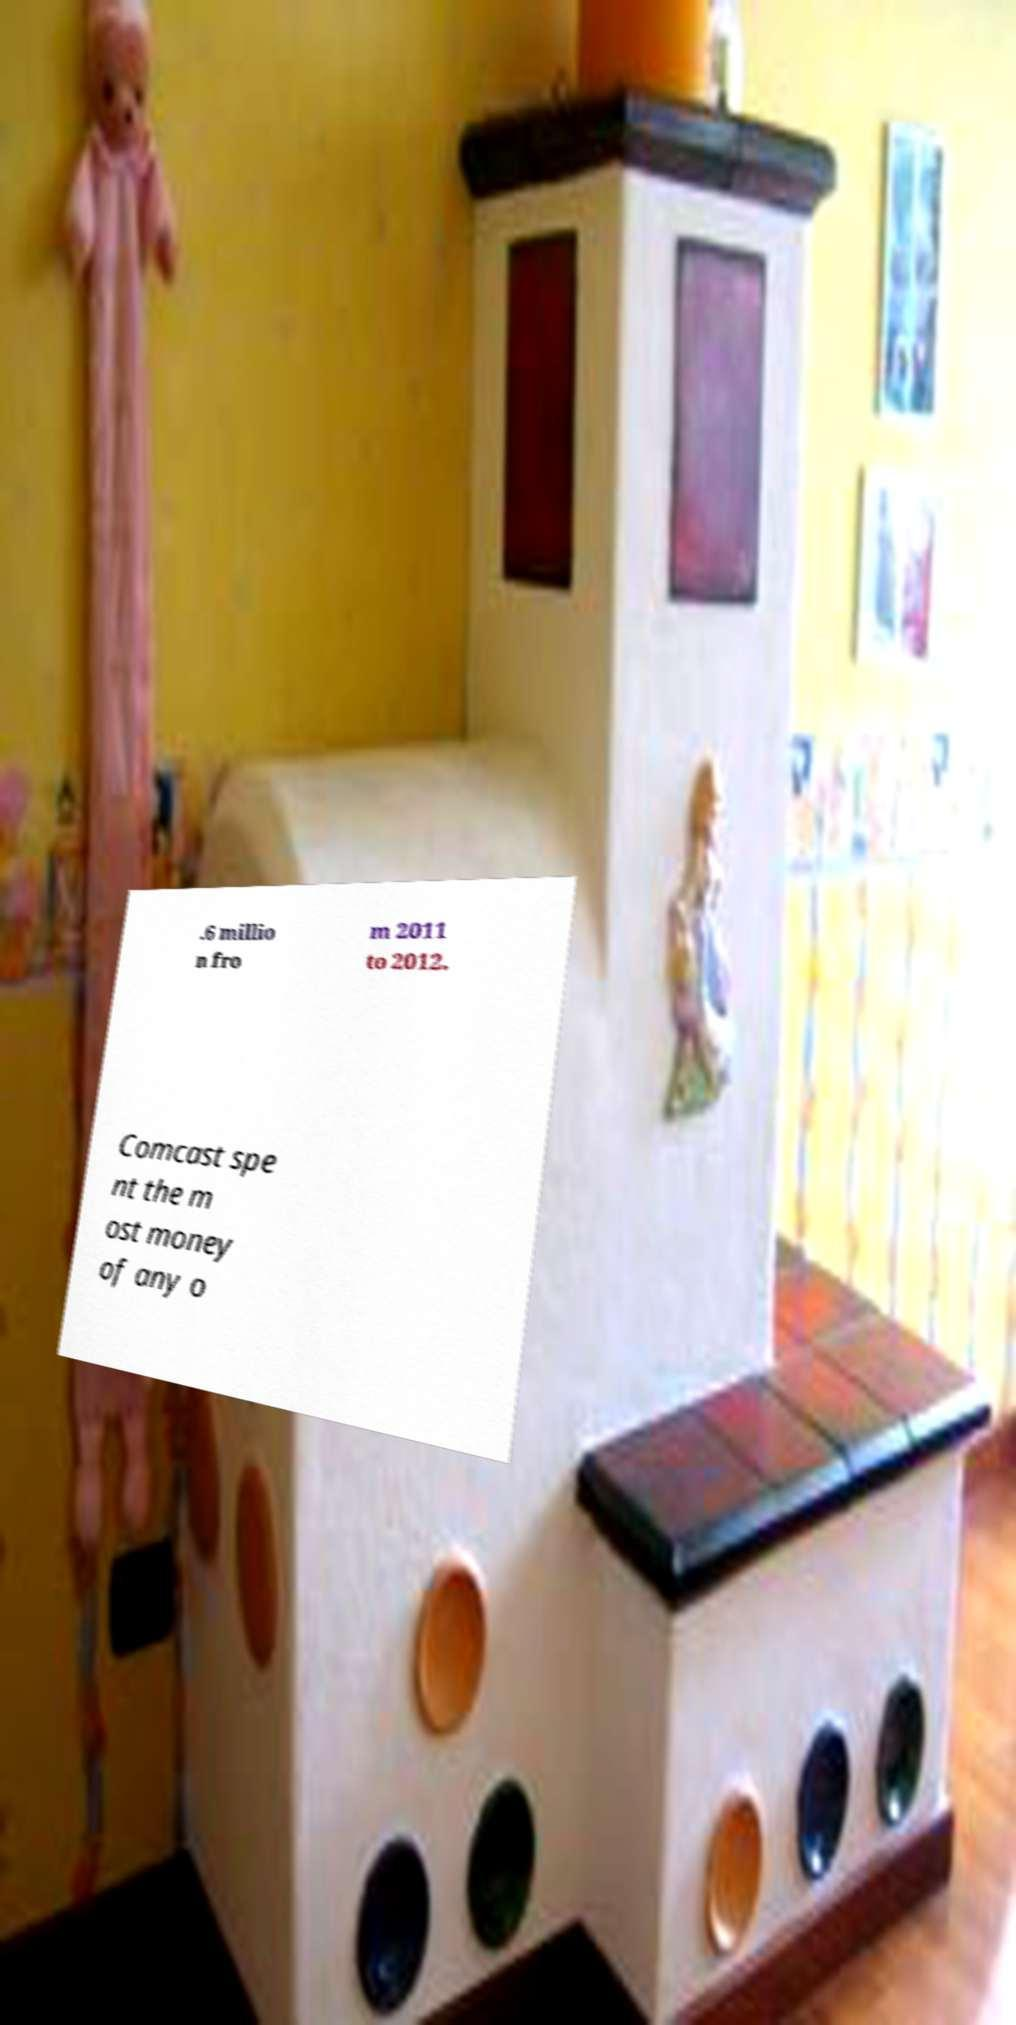Can you accurately transcribe the text from the provided image for me? .6 millio n fro m 2011 to 2012. Comcast spe nt the m ost money of any o 